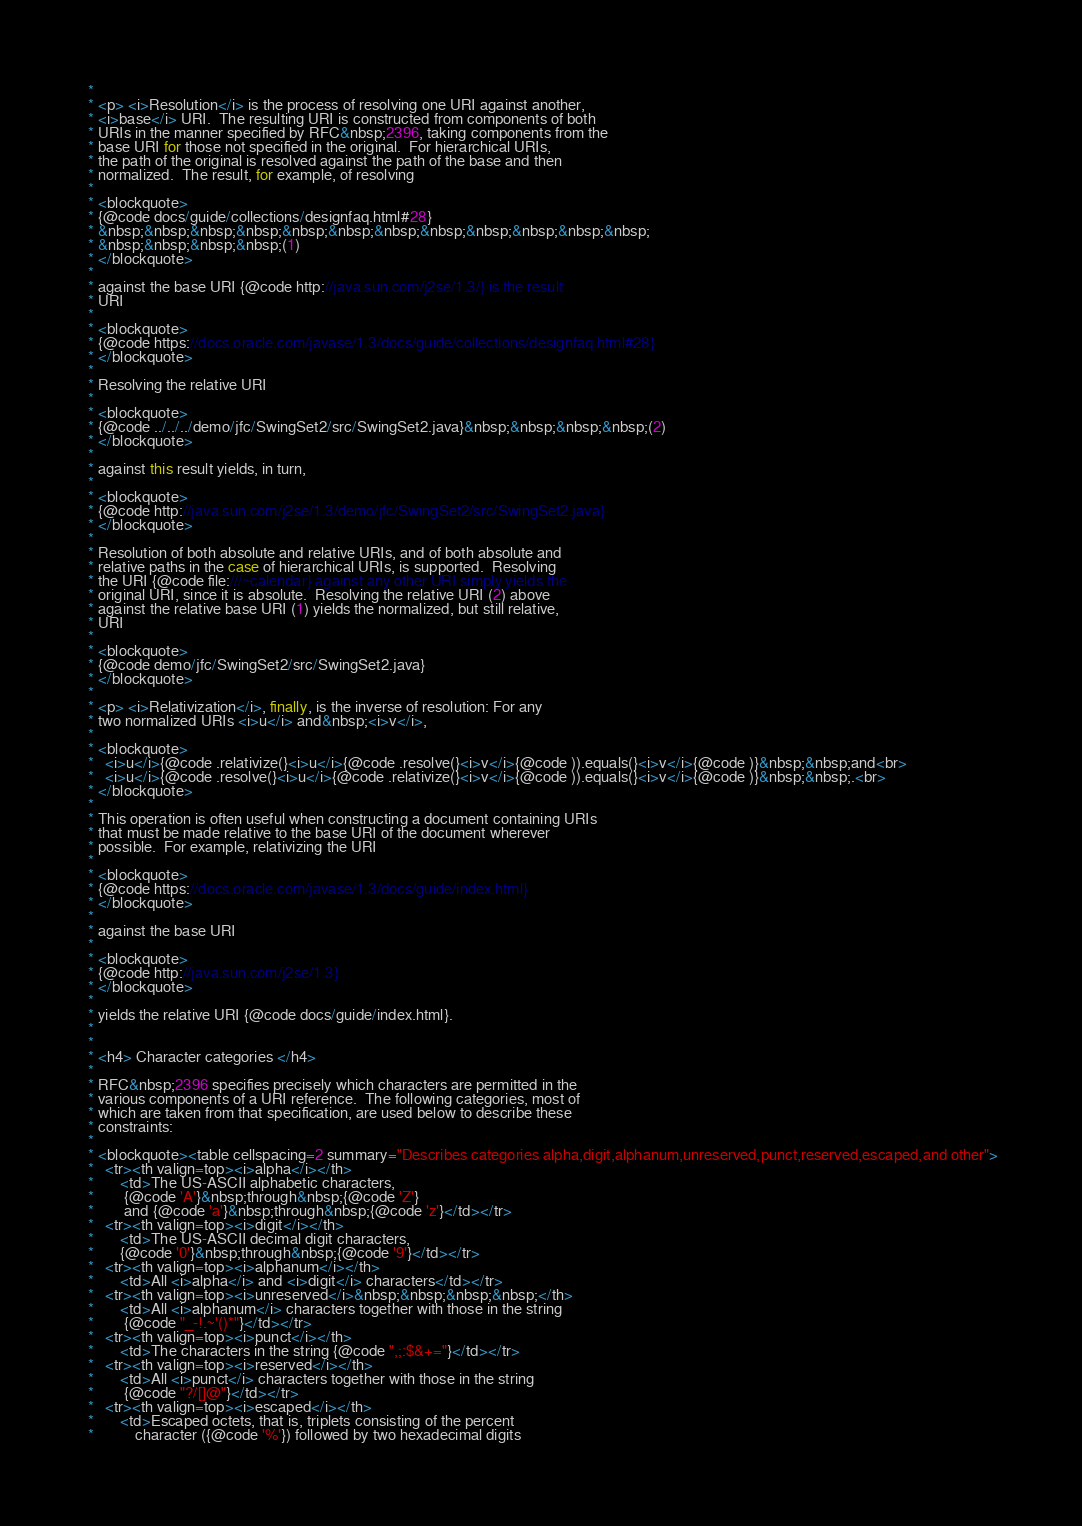Convert code to text. <code><loc_0><loc_0><loc_500><loc_500><_Java_> *
 * <p> <i>Resolution</i> is the process of resolving one URI against another,
 * <i>base</i> URI.  The resulting URI is constructed from components of both
 * URIs in the manner specified by RFC&nbsp;2396, taking components from the
 * base URI for those not specified in the original.  For hierarchical URIs,
 * the path of the original is resolved against the path of the base and then
 * normalized.  The result, for example, of resolving
 *
 * <blockquote>
 * {@code docs/guide/collections/designfaq.html#28}
 * &nbsp;&nbsp;&nbsp;&nbsp;&nbsp;&nbsp;&nbsp;&nbsp;&nbsp;&nbsp;&nbsp;&nbsp;
 * &nbsp;&nbsp;&nbsp;&nbsp;(1)
 * </blockquote>
 *
 * against the base URI {@code http://java.sun.com/j2se/1.3/} is the result
 * URI
 *
 * <blockquote>
 * {@code https://docs.oracle.com/javase/1.3/docs/guide/collections/designfaq.html#28}
 * </blockquote>
 *
 * Resolving the relative URI
 *
 * <blockquote>
 * {@code ../../../demo/jfc/SwingSet2/src/SwingSet2.java}&nbsp;&nbsp;&nbsp;&nbsp;(2)
 * </blockquote>
 *
 * against this result yields, in turn,
 *
 * <blockquote>
 * {@code http://java.sun.com/j2se/1.3/demo/jfc/SwingSet2/src/SwingSet2.java}
 * </blockquote>
 *
 * Resolution of both absolute and relative URIs, and of both absolute and
 * relative paths in the case of hierarchical URIs, is supported.  Resolving
 * the URI {@code file:///~calendar} against any other URI simply yields the
 * original URI, since it is absolute.  Resolving the relative URI (2) above
 * against the relative base URI (1) yields the normalized, but still relative,
 * URI
 *
 * <blockquote>
 * {@code demo/jfc/SwingSet2/src/SwingSet2.java}
 * </blockquote>
 *
 * <p> <i>Relativization</i>, finally, is the inverse of resolution: For any
 * two normalized URIs <i>u</i> and&nbsp;<i>v</i>,
 *
 * <blockquote>
 *   <i>u</i>{@code .relativize(}<i>u</i>{@code .resolve(}<i>v</i>{@code )).equals(}<i>v</i>{@code )}&nbsp;&nbsp;and<br>
 *   <i>u</i>{@code .resolve(}<i>u</i>{@code .relativize(}<i>v</i>{@code )).equals(}<i>v</i>{@code )}&nbsp;&nbsp;.<br>
 * </blockquote>
 *
 * This operation is often useful when constructing a document containing URIs
 * that must be made relative to the base URI of the document wherever
 * possible.  For example, relativizing the URI
 *
 * <blockquote>
 * {@code https://docs.oracle.com/javase/1.3/docs/guide/index.html}
 * </blockquote>
 *
 * against the base URI
 *
 * <blockquote>
 * {@code http://java.sun.com/j2se/1.3}
 * </blockquote>
 *
 * yields the relative URI {@code docs/guide/index.html}.
 *
 *
 * <h4> Character categories </h4>
 *
 * RFC&nbsp;2396 specifies precisely which characters are permitted in the
 * various components of a URI reference.  The following categories, most of
 * which are taken from that specification, are used below to describe these
 * constraints:
 *
 * <blockquote><table cellspacing=2 summary="Describes categories alpha,digit,alphanum,unreserved,punct,reserved,escaped,and other">
 *   <tr><th valign=top><i>alpha</i></th>
 *       <td>The US-ASCII alphabetic characters,
 *        {@code 'A'}&nbsp;through&nbsp;{@code 'Z'}
 *        and {@code 'a'}&nbsp;through&nbsp;{@code 'z'}</td></tr>
 *   <tr><th valign=top><i>digit</i></th>
 *       <td>The US-ASCII decimal digit characters,
 *       {@code '0'}&nbsp;through&nbsp;{@code '9'}</td></tr>
 *   <tr><th valign=top><i>alphanum</i></th>
 *       <td>All <i>alpha</i> and <i>digit</i> characters</td></tr>
 *   <tr><th valign=top><i>unreserved</i>&nbsp;&nbsp;&nbsp;&nbsp;</th>
 *       <td>All <i>alphanum</i> characters together with those in the string
 *        {@code "_-!.~'()*"}</td></tr>
 *   <tr><th valign=top><i>punct</i></th>
 *       <td>The characters in the string {@code ",;:$&+="}</td></tr>
 *   <tr><th valign=top><i>reserved</i></th>
 *       <td>All <i>punct</i> characters together with those in the string
 *        {@code "?/[]@"}</td></tr>
 *   <tr><th valign=top><i>escaped</i></th>
 *       <td>Escaped octets, that is, triplets consisting of the percent
 *           character ({@code '%'}) followed by two hexadecimal digits</code> 